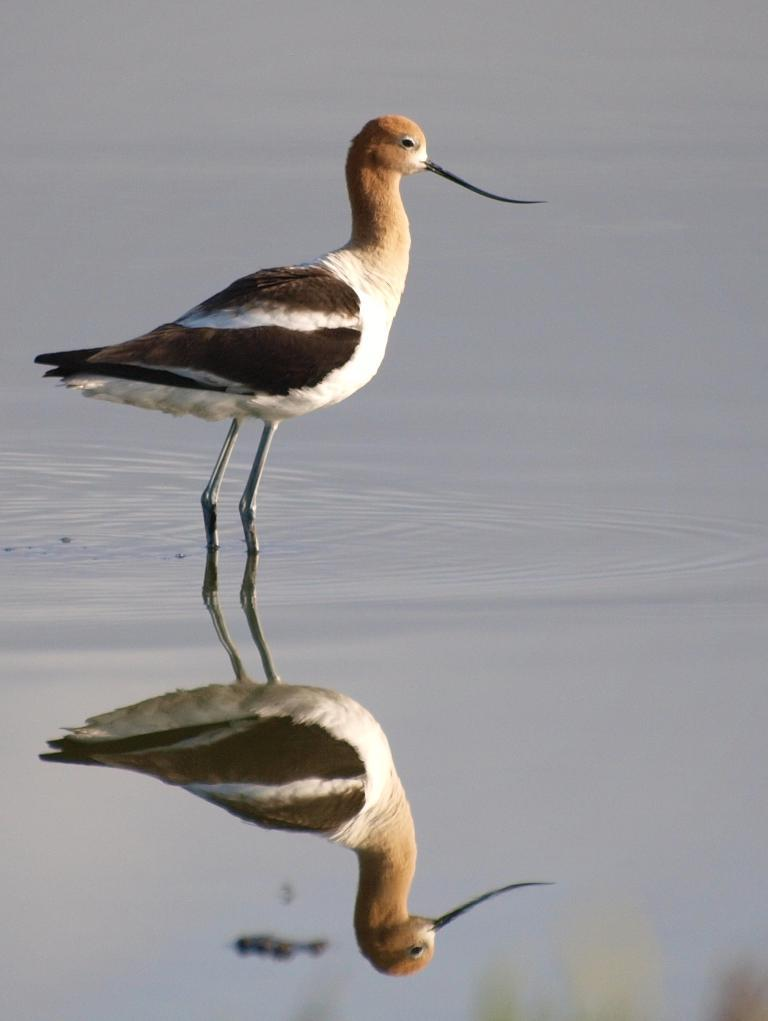What type of animal is in the image? There is a bird in the image. Where is the bird located in the image? The bird is in the water. How many kittens are playing with the person holding a rifle in the image? There are no kittens, person, or rifle present in the image; it only features a bird in the water. 